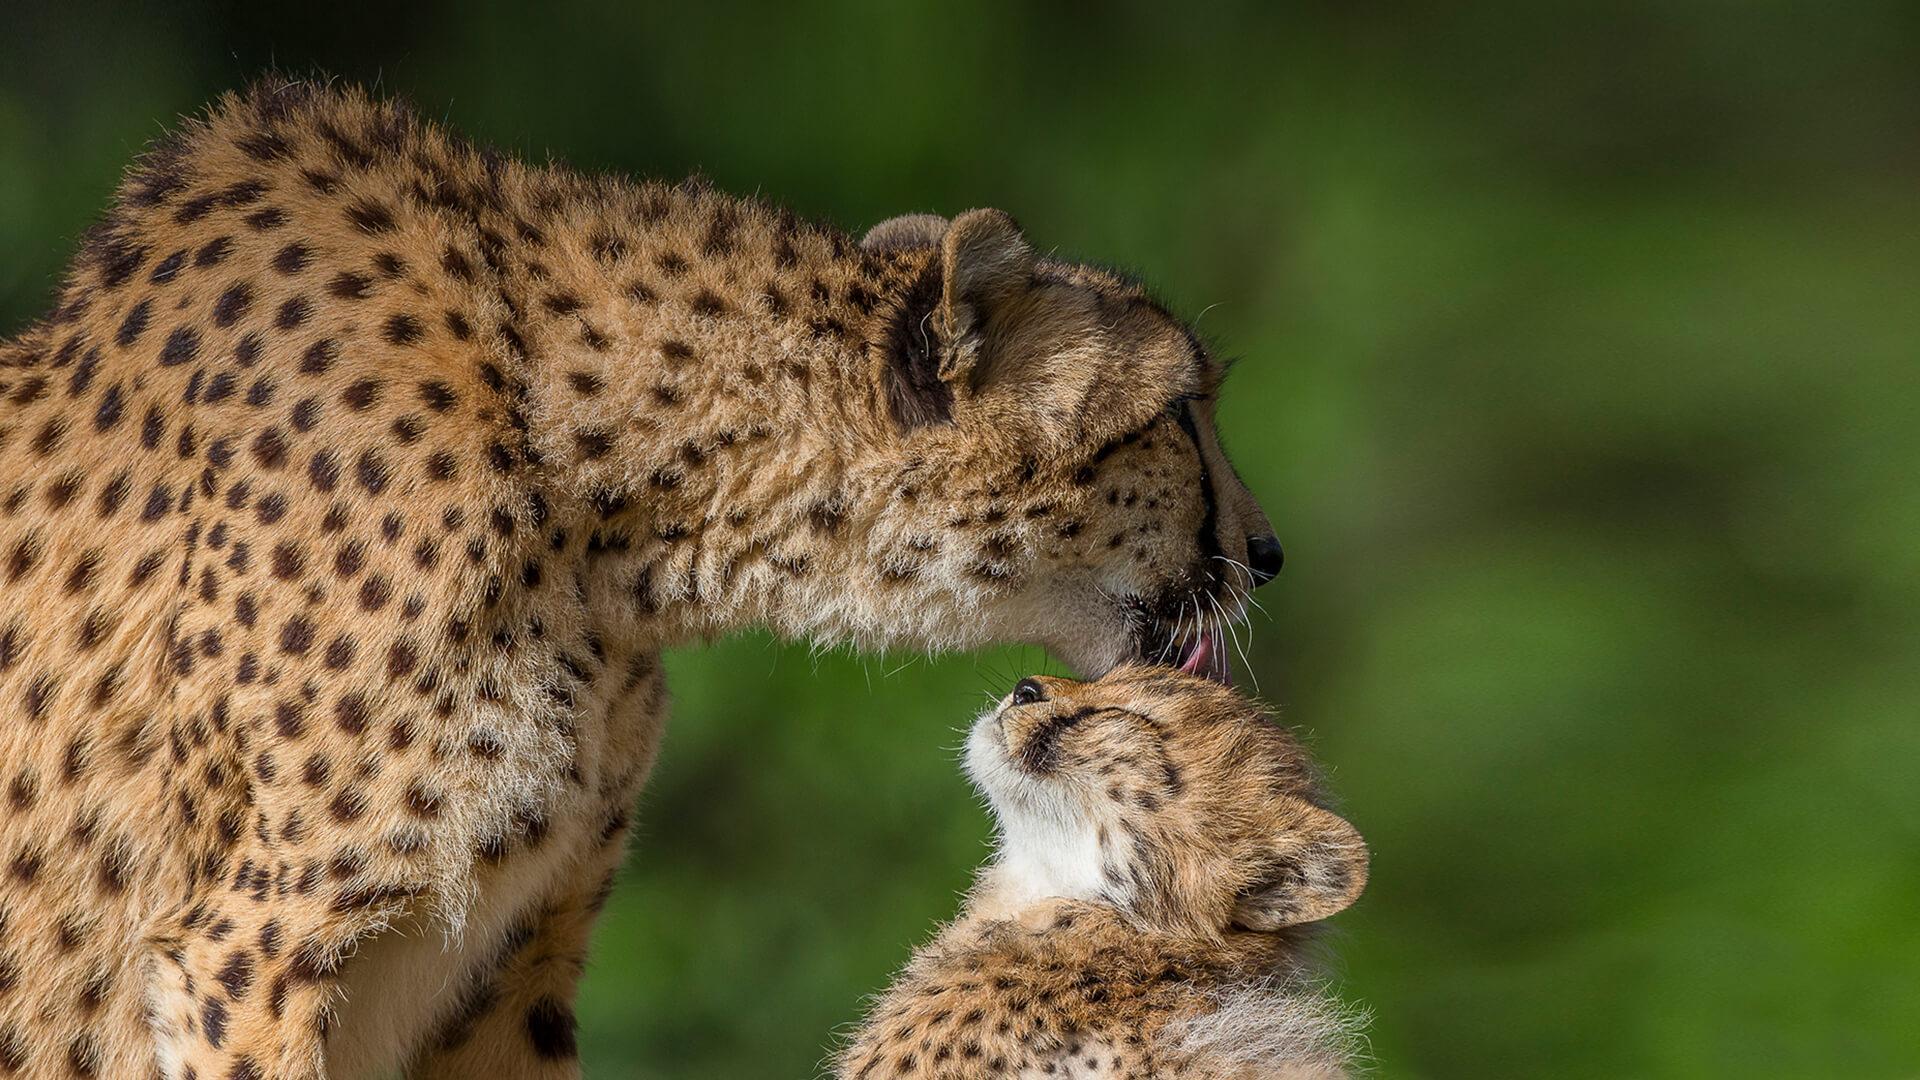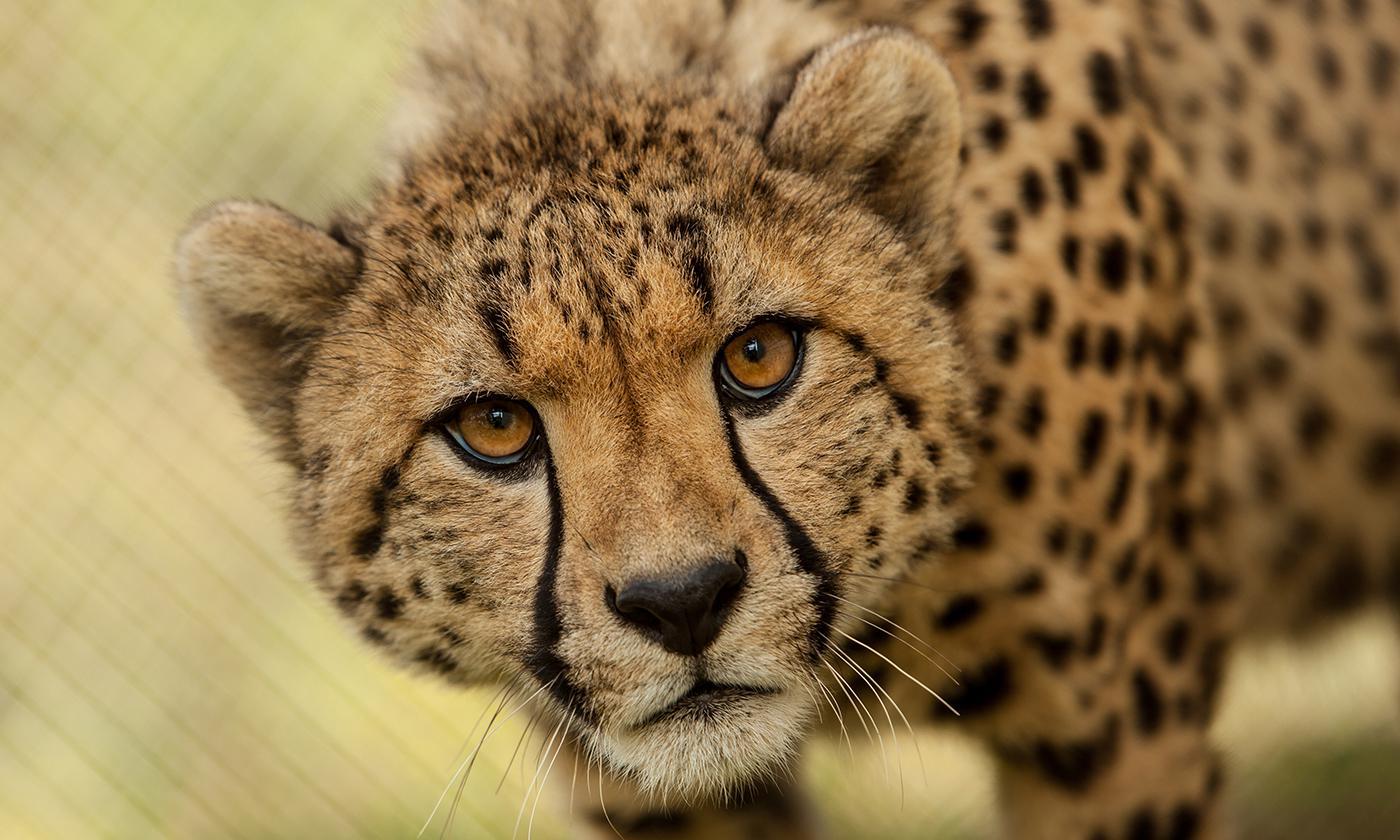The first image is the image on the left, the second image is the image on the right. Given the left and right images, does the statement "The cheetah on the right image is a close up of its face while looking at the camera." hold true? Answer yes or no. Yes. 